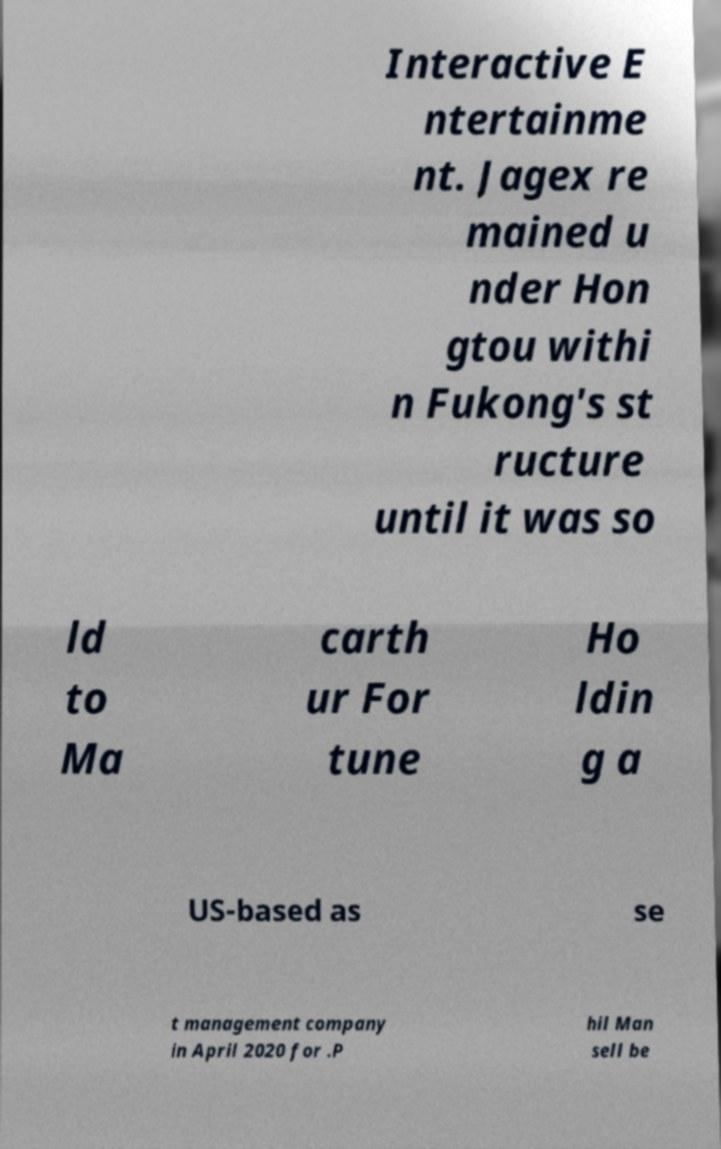There's text embedded in this image that I need extracted. Can you transcribe it verbatim? Interactive E ntertainme nt. Jagex re mained u nder Hon gtou withi n Fukong's st ructure until it was so ld to Ma carth ur For tune Ho ldin g a US-based as se t management company in April 2020 for .P hil Man sell be 